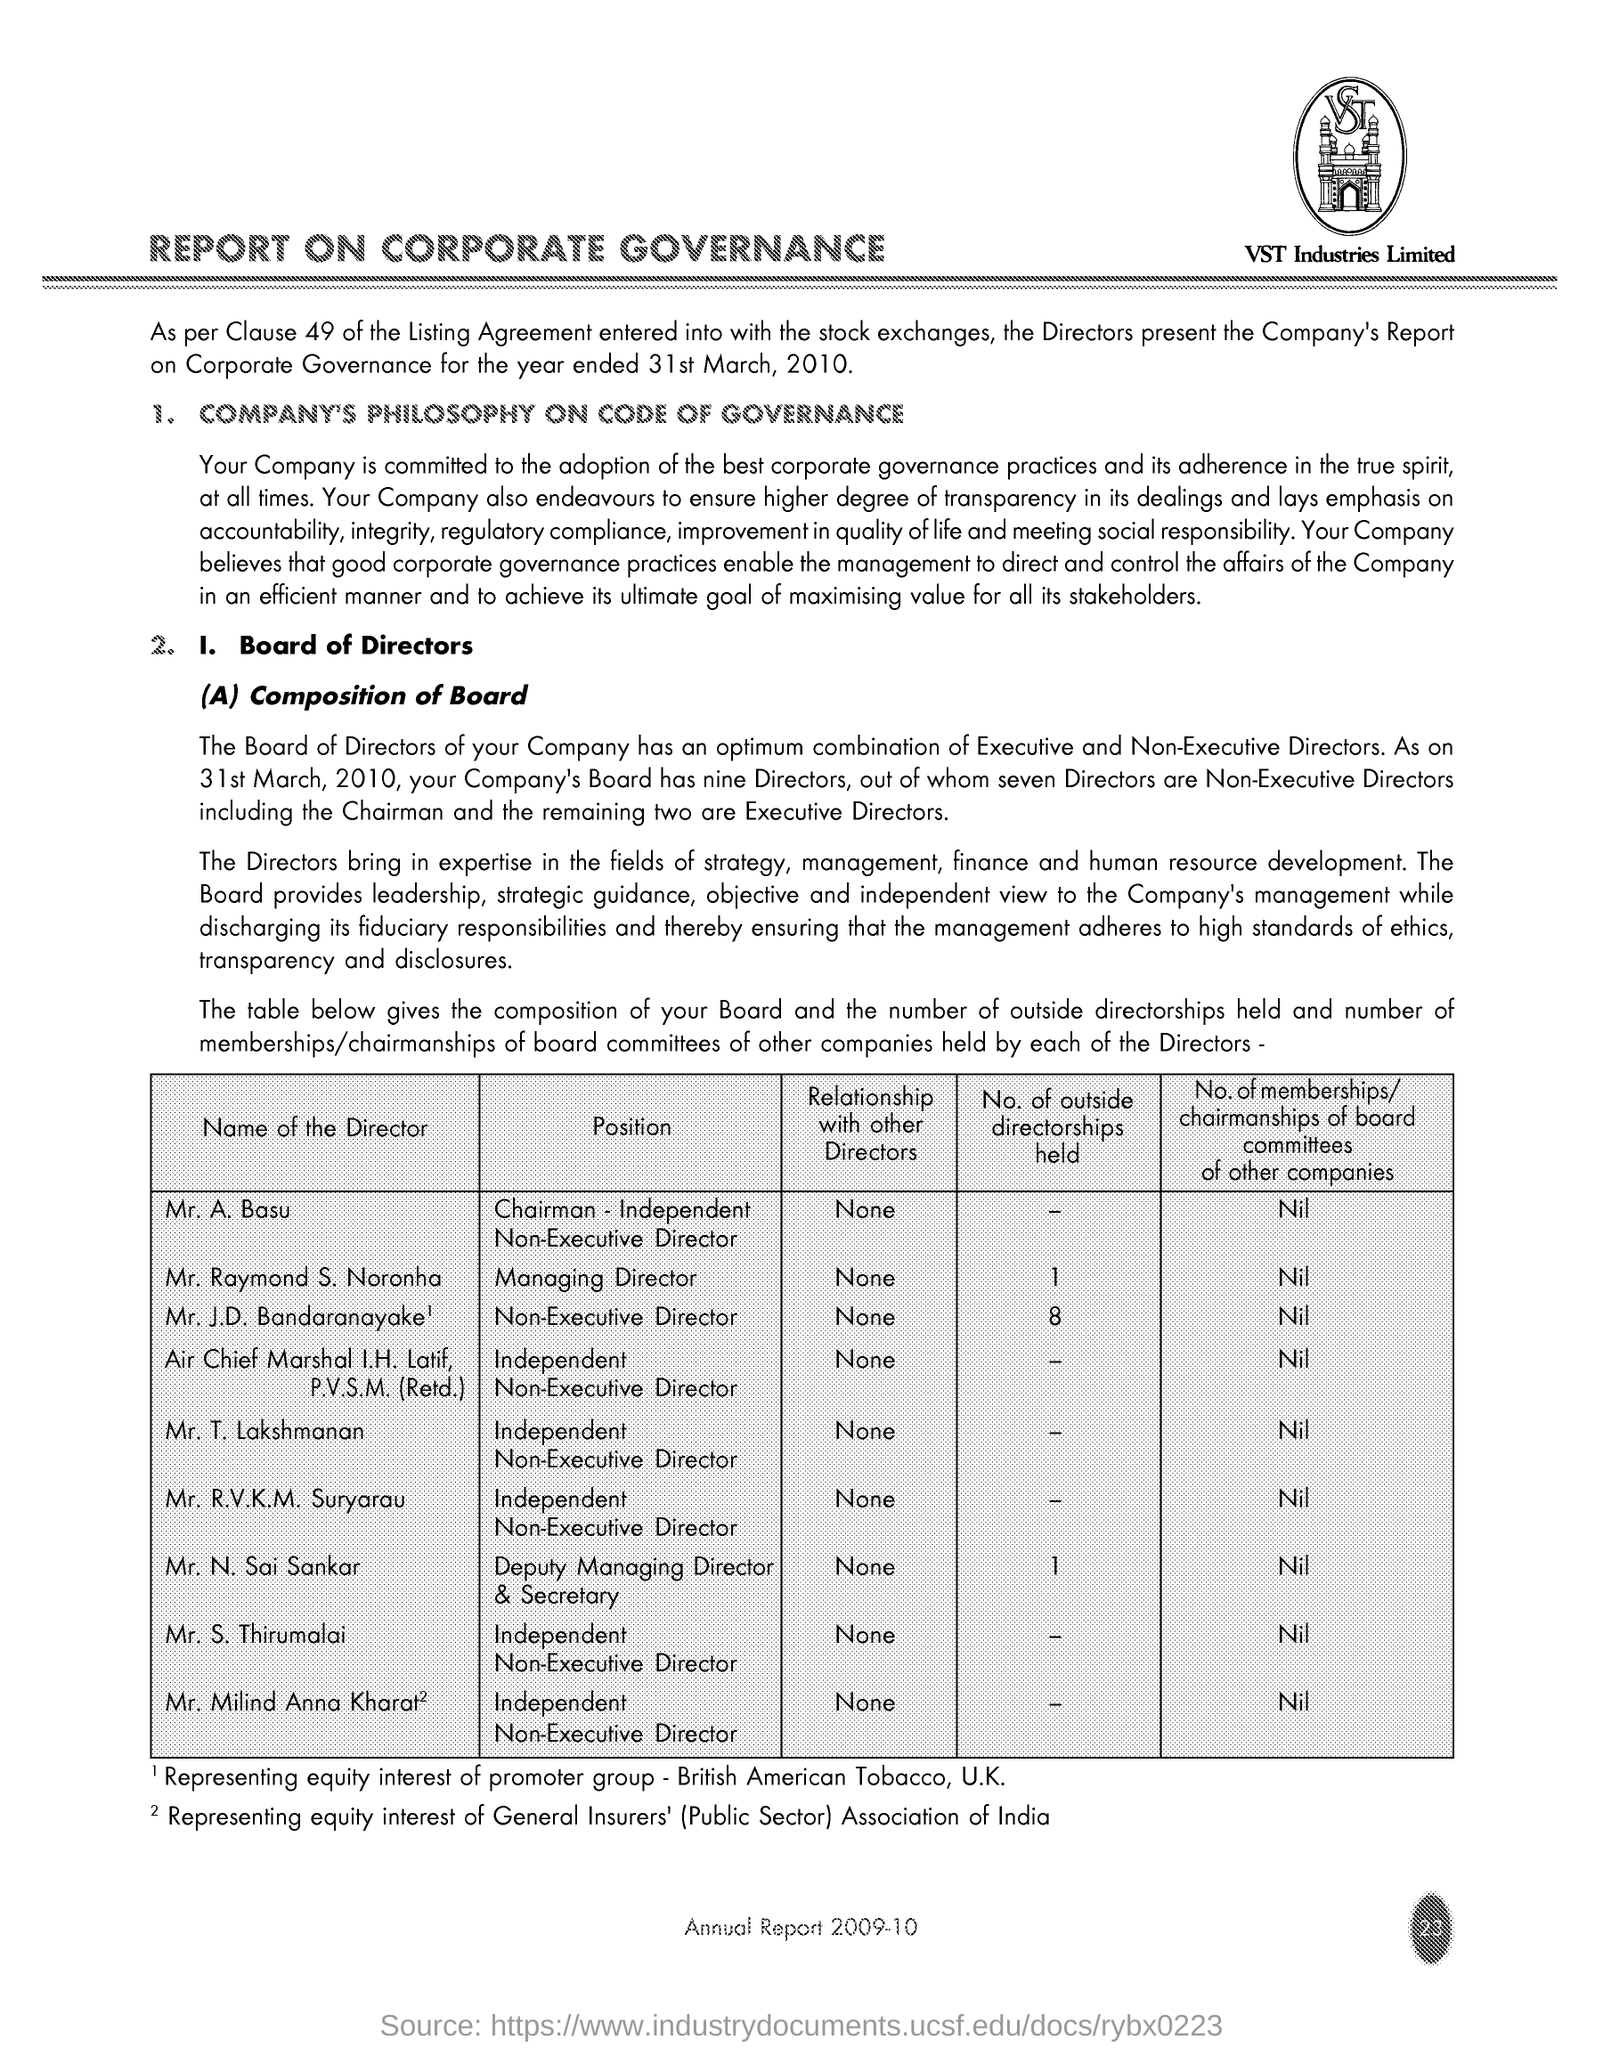Draw attention to some important aspects in this diagram. The company in question is called VST Industries Limited. The title of the document is 'Report on Corporate Governance'. 